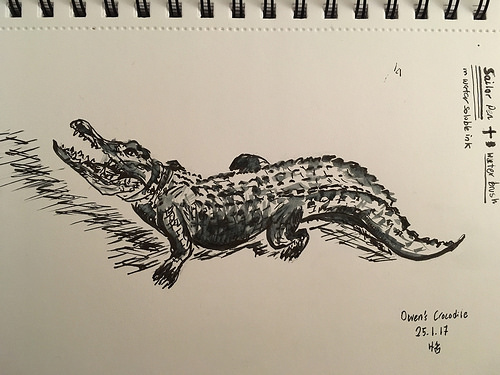<image>
Can you confirm if the crocodile is on the floor? Yes. Looking at the image, I can see the crocodile is positioned on top of the floor, with the floor providing support. 